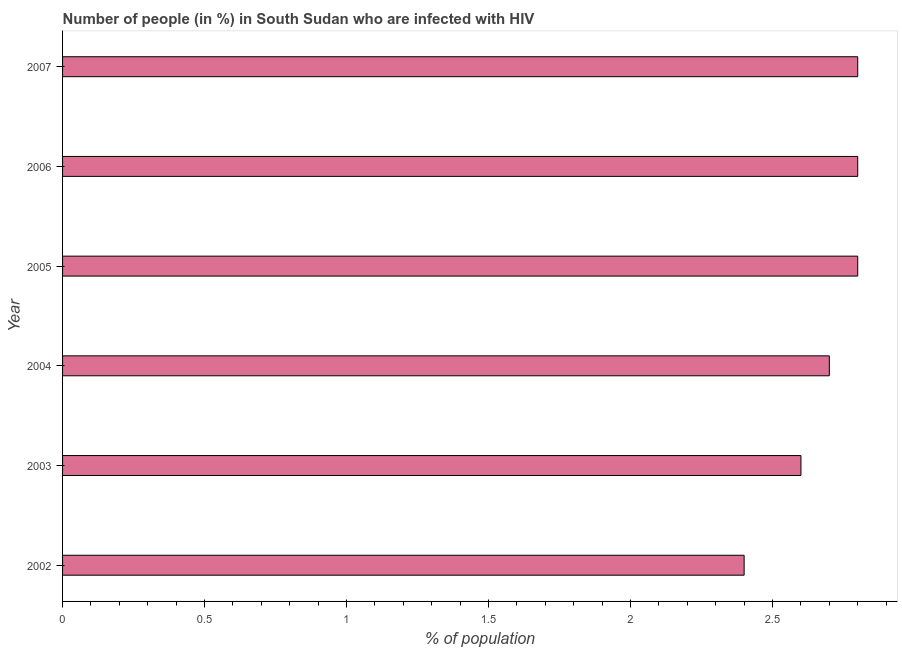Does the graph contain any zero values?
Ensure brevity in your answer.  No. Does the graph contain grids?
Your answer should be very brief. No. What is the title of the graph?
Keep it short and to the point. Number of people (in %) in South Sudan who are infected with HIV. What is the label or title of the X-axis?
Keep it short and to the point. % of population. What is the difference between the number of people infected with hiv in 2002 and 2007?
Give a very brief answer. -0.4. What is the average number of people infected with hiv per year?
Your response must be concise. 2.68. What is the median number of people infected with hiv?
Offer a terse response. 2.75. Do a majority of the years between 2002 and 2004 (inclusive) have number of people infected with hiv greater than 2.5 %?
Ensure brevity in your answer.  Yes. Is the number of people infected with hiv in 2002 less than that in 2003?
Offer a very short reply. Yes. Is the sum of the number of people infected with hiv in 2002 and 2006 greater than the maximum number of people infected with hiv across all years?
Make the answer very short. Yes. In how many years, is the number of people infected with hiv greater than the average number of people infected with hiv taken over all years?
Keep it short and to the point. 4. How many years are there in the graph?
Give a very brief answer. 6. Are the values on the major ticks of X-axis written in scientific E-notation?
Offer a very short reply. No. What is the % of population of 2002?
Give a very brief answer. 2.4. What is the % of population in 2006?
Ensure brevity in your answer.  2.8. What is the % of population of 2007?
Offer a very short reply. 2.8. What is the difference between the % of population in 2002 and 2003?
Provide a short and direct response. -0.2. What is the difference between the % of population in 2002 and 2004?
Your response must be concise. -0.3. What is the difference between the % of population in 2002 and 2006?
Your answer should be very brief. -0.4. What is the difference between the % of population in 2003 and 2005?
Your answer should be compact. -0.2. What is the difference between the % of population in 2003 and 2006?
Provide a succinct answer. -0.2. What is the difference between the % of population in 2004 and 2006?
Your answer should be compact. -0.1. What is the difference between the % of population in 2004 and 2007?
Offer a very short reply. -0.1. What is the difference between the % of population in 2006 and 2007?
Provide a succinct answer. 0. What is the ratio of the % of population in 2002 to that in 2003?
Offer a very short reply. 0.92. What is the ratio of the % of population in 2002 to that in 2004?
Your response must be concise. 0.89. What is the ratio of the % of population in 2002 to that in 2005?
Make the answer very short. 0.86. What is the ratio of the % of population in 2002 to that in 2006?
Your answer should be compact. 0.86. What is the ratio of the % of population in 2002 to that in 2007?
Provide a succinct answer. 0.86. What is the ratio of the % of population in 2003 to that in 2005?
Provide a succinct answer. 0.93. What is the ratio of the % of population in 2003 to that in 2006?
Your answer should be compact. 0.93. What is the ratio of the % of population in 2003 to that in 2007?
Make the answer very short. 0.93. What is the ratio of the % of population in 2004 to that in 2006?
Keep it short and to the point. 0.96. What is the ratio of the % of population in 2004 to that in 2007?
Offer a very short reply. 0.96. What is the ratio of the % of population in 2005 to that in 2006?
Give a very brief answer. 1. What is the ratio of the % of population in 2005 to that in 2007?
Give a very brief answer. 1. 